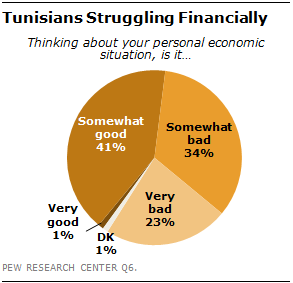Draw attention to some important aspects in this diagram. DK is the smallest segment, and it is true. The difference between the largest and smallest segments is greater than the median, according to the data. 